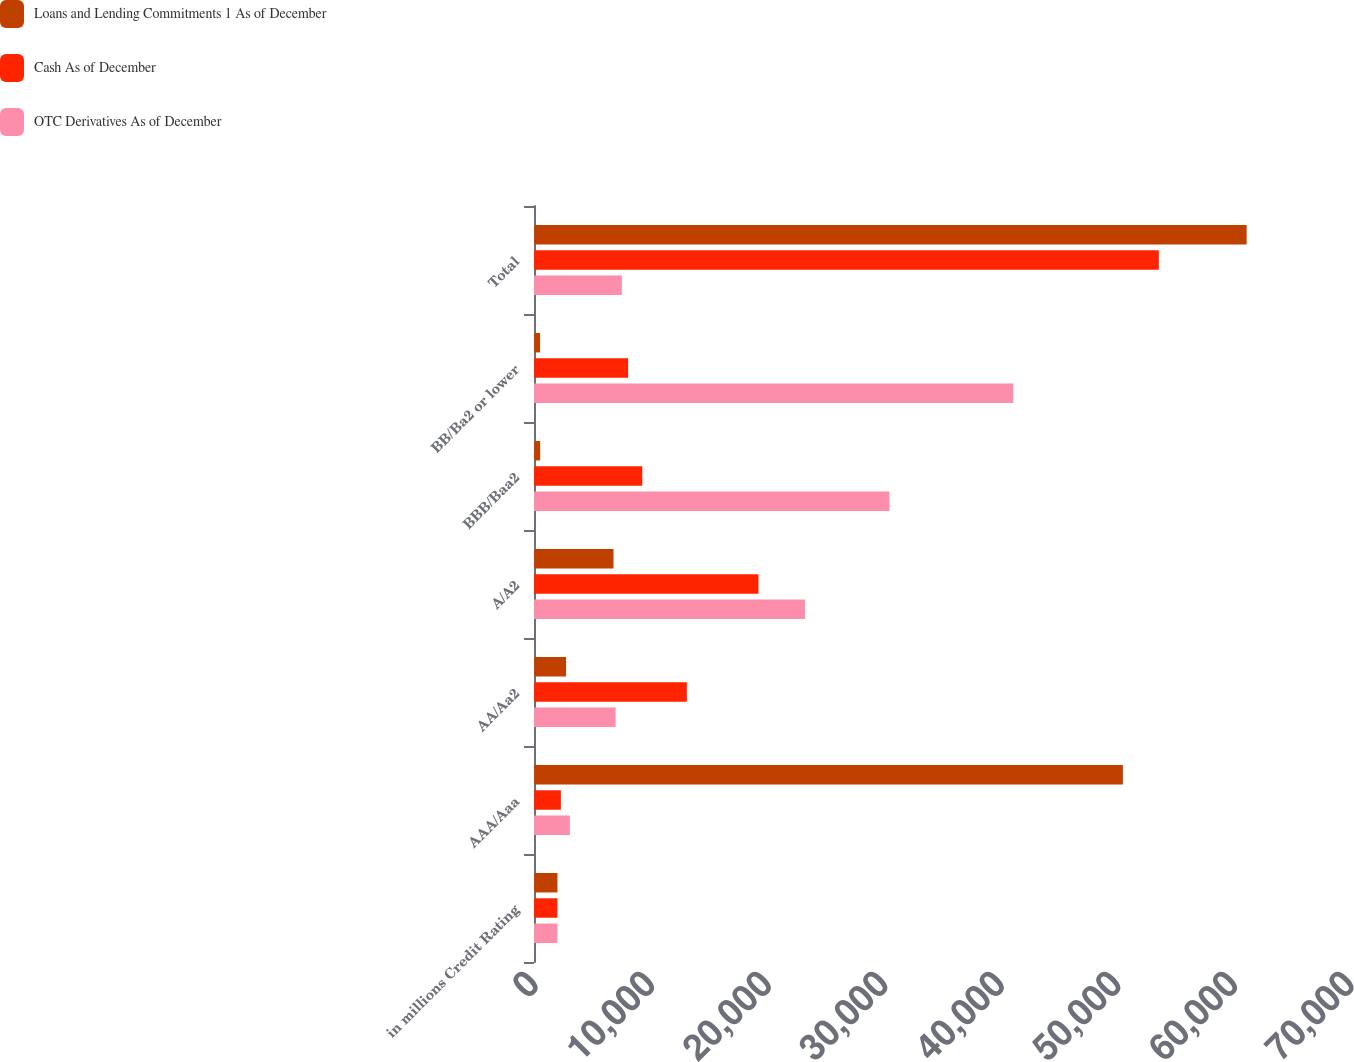Convert chart. <chart><loc_0><loc_0><loc_500><loc_500><stacked_bar_chart><ecel><fcel>in millions Credit Rating<fcel>AAA/Aaa<fcel>AA/Aa2<fcel>A/A2<fcel>BBB/Baa2<fcel>BB/Ba2 or lower<fcel>Total<nl><fcel>Loans and Lending Commitments 1 As of December<fcel>2013<fcel>50519<fcel>2748<fcel>6821<fcel>527<fcel>518<fcel>61133<nl><fcel>Cash As of December<fcel>2013<fcel>2306<fcel>13113<fcel>19257<fcel>9289<fcel>8074<fcel>53602<nl><fcel>OTC Derivatives As of December<fcel>2013<fcel>3079<fcel>7001<fcel>23250<fcel>30496<fcel>41114<fcel>7537.5<nl></chart> 